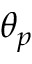<formula> <loc_0><loc_0><loc_500><loc_500>\theta _ { p }</formula> 